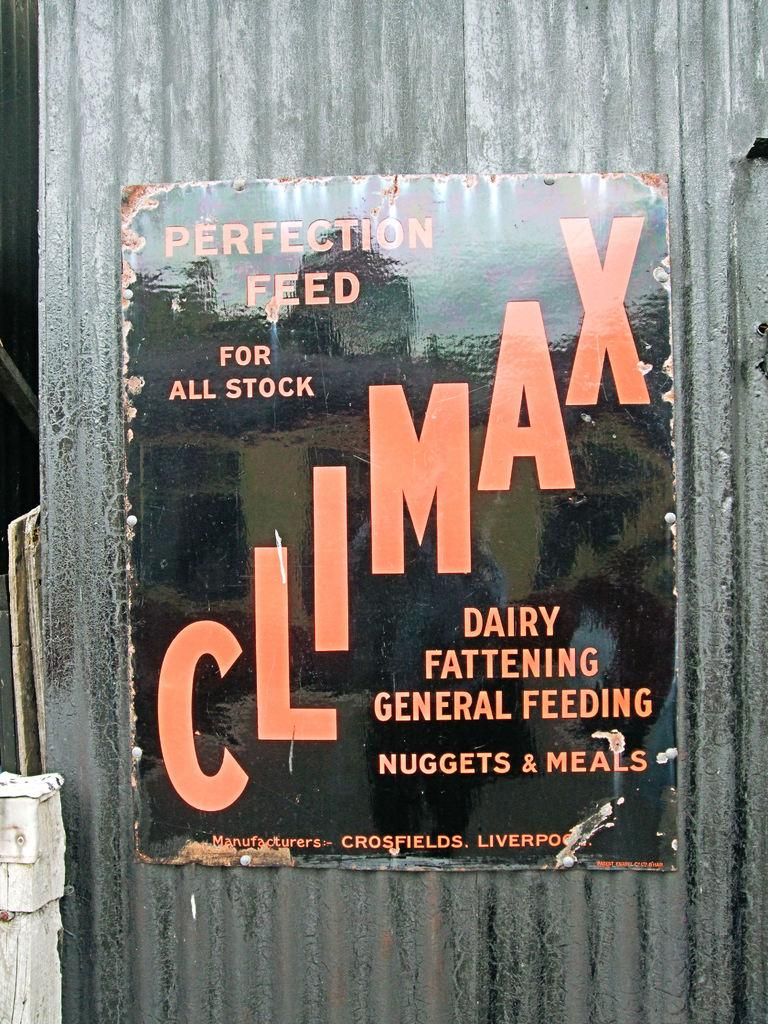<image>
Relay a brief, clear account of the picture shown. Sign that says "Dairy Fattening General Feeding' on  a wall. 